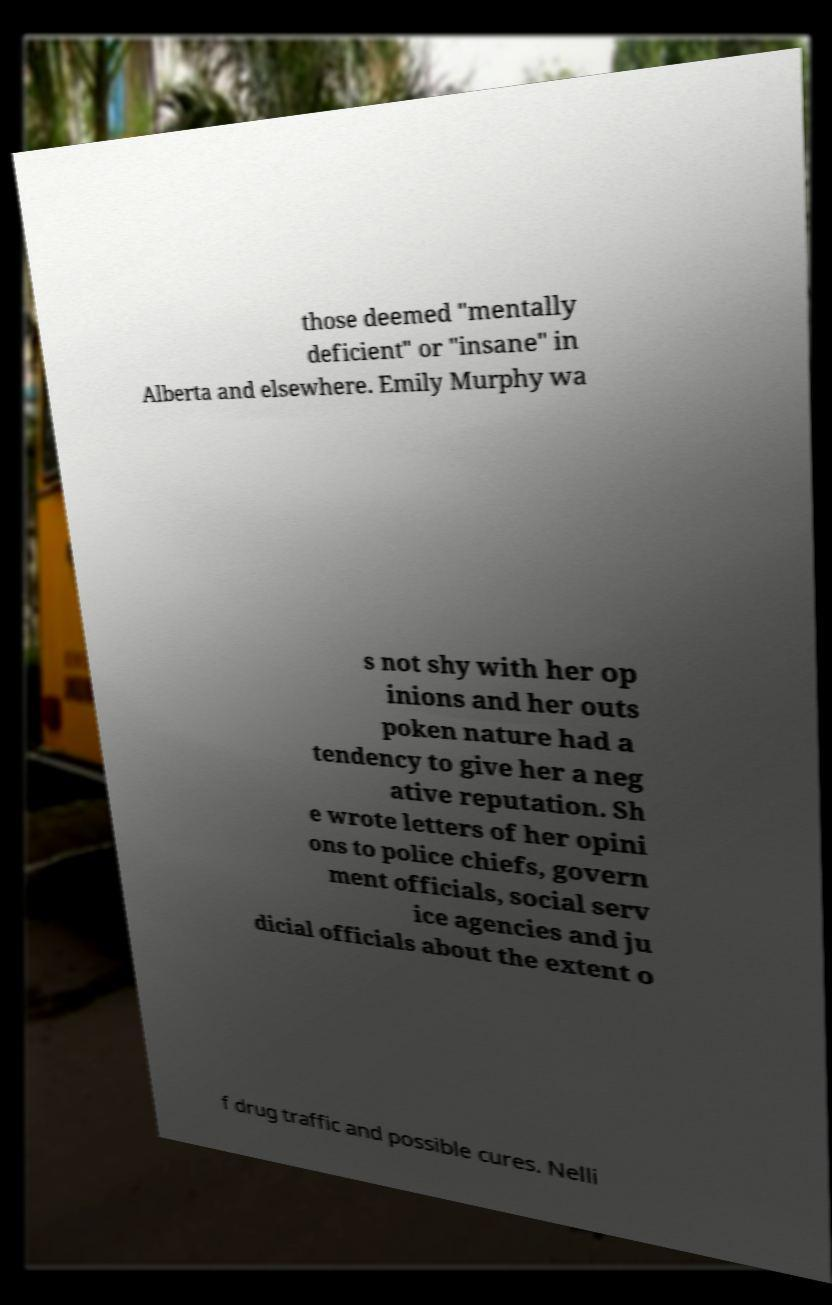I need the written content from this picture converted into text. Can you do that? those deemed "mentally deficient" or "insane" in Alberta and elsewhere. Emily Murphy wa s not shy with her op inions and her outs poken nature had a tendency to give her a neg ative reputation. Sh e wrote letters of her opini ons to police chiefs, govern ment officials, social serv ice agencies and ju dicial officials about the extent o f drug traffic and possible cures. Nelli 